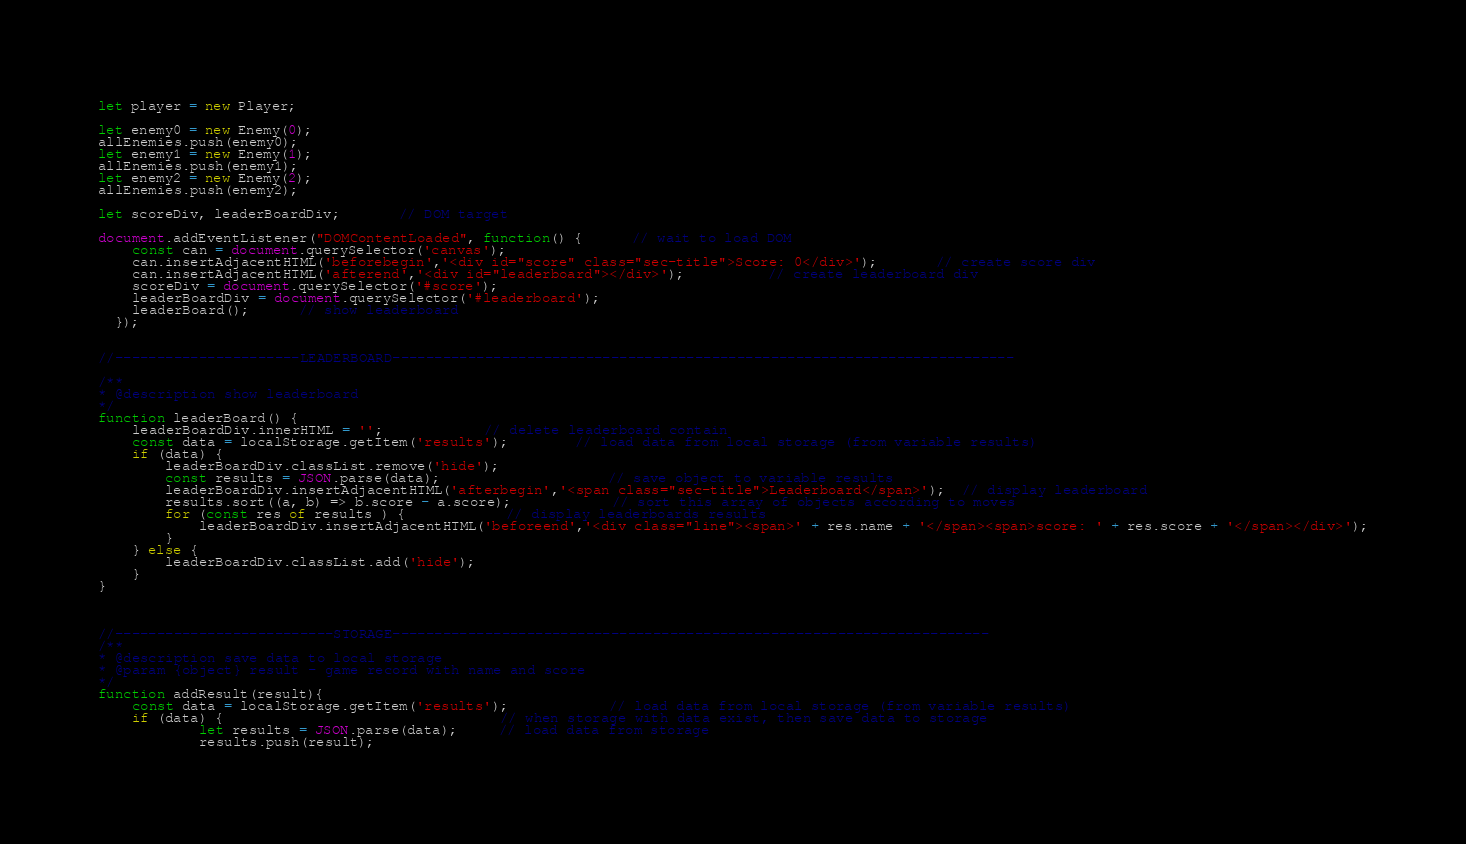Convert code to text. <code><loc_0><loc_0><loc_500><loc_500><_JavaScript_>
let player = new Player;

let enemy0 = new Enemy(0);
allEnemies.push(enemy0);
let enemy1 = new Enemy(1);
allEnemies.push(enemy1);
let enemy2 = new Enemy(2);
allEnemies.push(enemy2);

let scoreDiv, leaderBoardDiv;       // DOM target

document.addEventListener("DOMContentLoaded", function() {      // wait to load DOM
    const can = document.querySelector('canvas');
    can.insertAdjacentHTML('beforebegin','<div id="score" class="sec-title">Score: 0</div>');       // create score div
    can.insertAdjacentHTML('afterend','<div id="leaderboard"></div>');          // create leaderboard div
    scoreDiv = document.querySelector('#score');
    leaderBoardDiv = document.querySelector('#leaderboard');
    leaderBoard();      // show leaderboard
  });


//----------------------LEADERBOARD--------------------------------------------------------------------------

/**
* @description show leaderboard
*/
function leaderBoard() {
	leaderBoardDiv.innerHTML = '';			// delete leaderboard contain
	const data = localStorage.getItem('results');		// load data from local storage (from variable results)
	if (data) {
        leaderBoardDiv.classList.remove('hide');
        const results = JSON.parse(data);					// save object to variable results
        leaderBoardDiv.insertAdjacentHTML('afterbegin','<span class="sec-title">Leaderboard</span>');  // display leaderboard
        results.sort((a, b) => b.score - a.score);			// sort this array of objects according to moves
  		for (const res of results ) {			// display leaderboards results
            leaderBoardDiv.insertAdjacentHTML('beforeend','<div class="line"><span>' + res.name + '</span><span>score: ' + res.score + '</span></div>');
	  	}
	} else {
        leaderBoardDiv.classList.add('hide');
    }
}



//--------------------------STORAGE-----------------------------------------------------------------------
/**
* @description save data to local storage
* @param {object} result - game record with name and score
*/
function addResult(result){
	const data = localStorage.getItem('results');			// load data from local storage (from variable results)
	if (data) {                                 // when storage with data exist, then save data to storage
	  		let results = JSON.parse(data);     // load data from storage
	  		results.push(result);</code> 